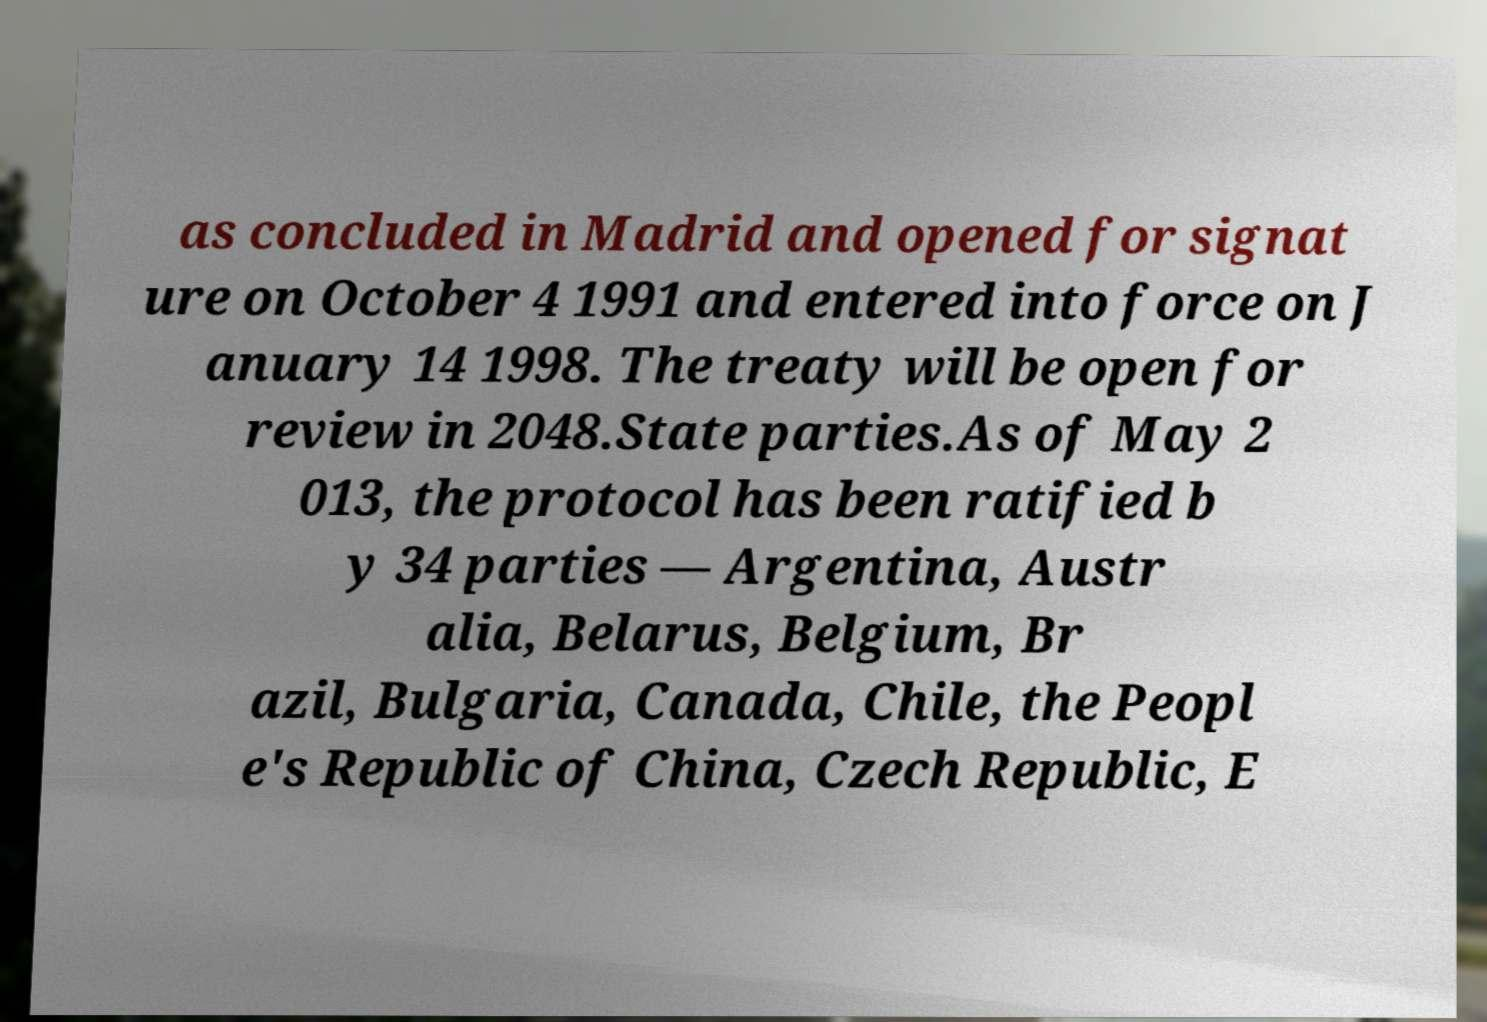Could you assist in decoding the text presented in this image and type it out clearly? as concluded in Madrid and opened for signat ure on October 4 1991 and entered into force on J anuary 14 1998. The treaty will be open for review in 2048.State parties.As of May 2 013, the protocol has been ratified b y 34 parties — Argentina, Austr alia, Belarus, Belgium, Br azil, Bulgaria, Canada, Chile, the Peopl e's Republic of China, Czech Republic, E 